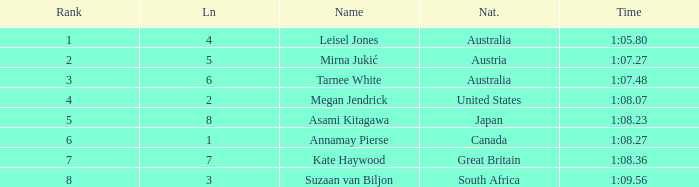What is the Nationality of the Swimmer in Lane 4 or larger with a Rank of 5 or more? Great Britain. 